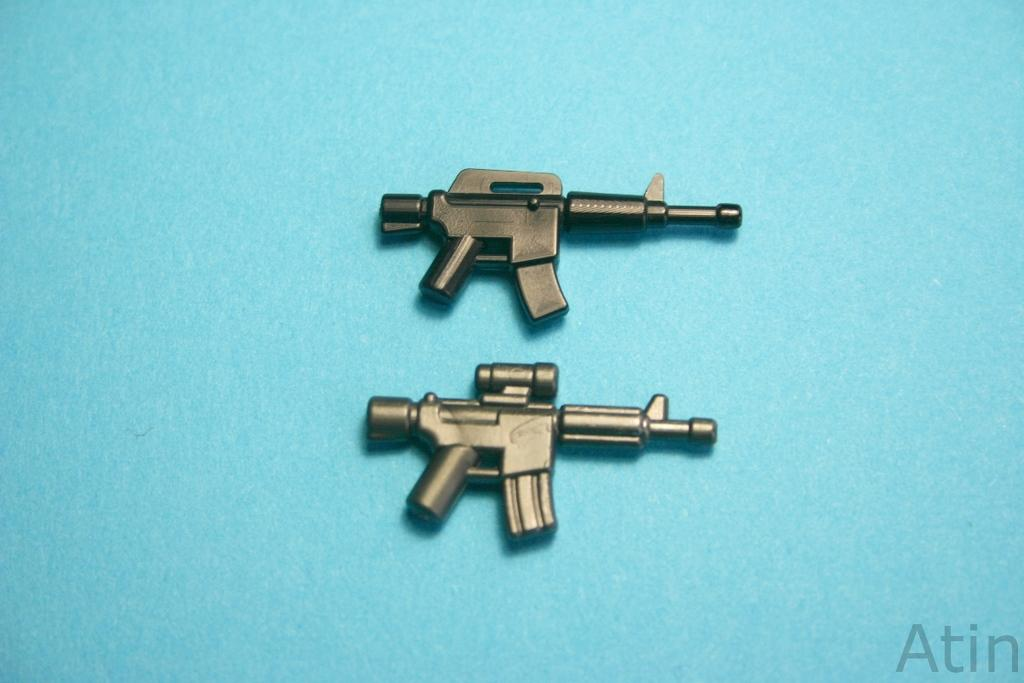What objects are present in the image? There are two toy guns in the image. What color are the toy guns? The toy guns are black in color. What can be seen in the background of the image? The background of the image is blue. What type of clam is being used as a prop in the image? There is no clam present in the image; it features two black toy guns. What appliance is being used to create the sleet effect in the image? There is no sleet effect or appliance present in the image. 